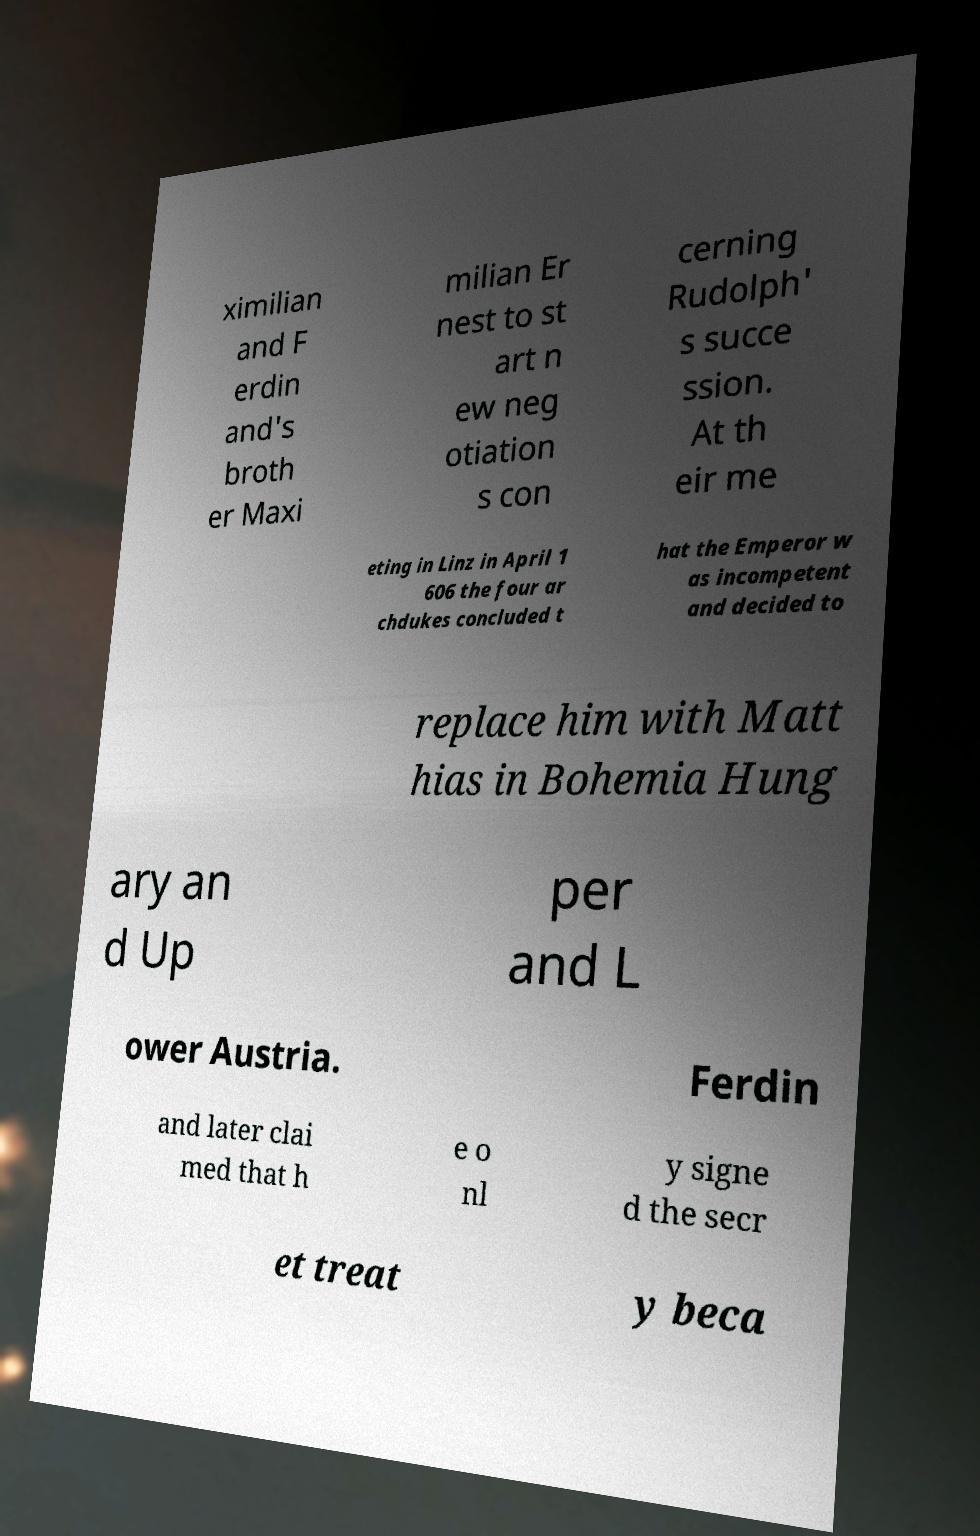Can you accurately transcribe the text from the provided image for me? ximilian and F erdin and's broth er Maxi milian Er nest to st art n ew neg otiation s con cerning Rudolph' s succe ssion. At th eir me eting in Linz in April 1 606 the four ar chdukes concluded t hat the Emperor w as incompetent and decided to replace him with Matt hias in Bohemia Hung ary an d Up per and L ower Austria. Ferdin and later clai med that h e o nl y signe d the secr et treat y beca 